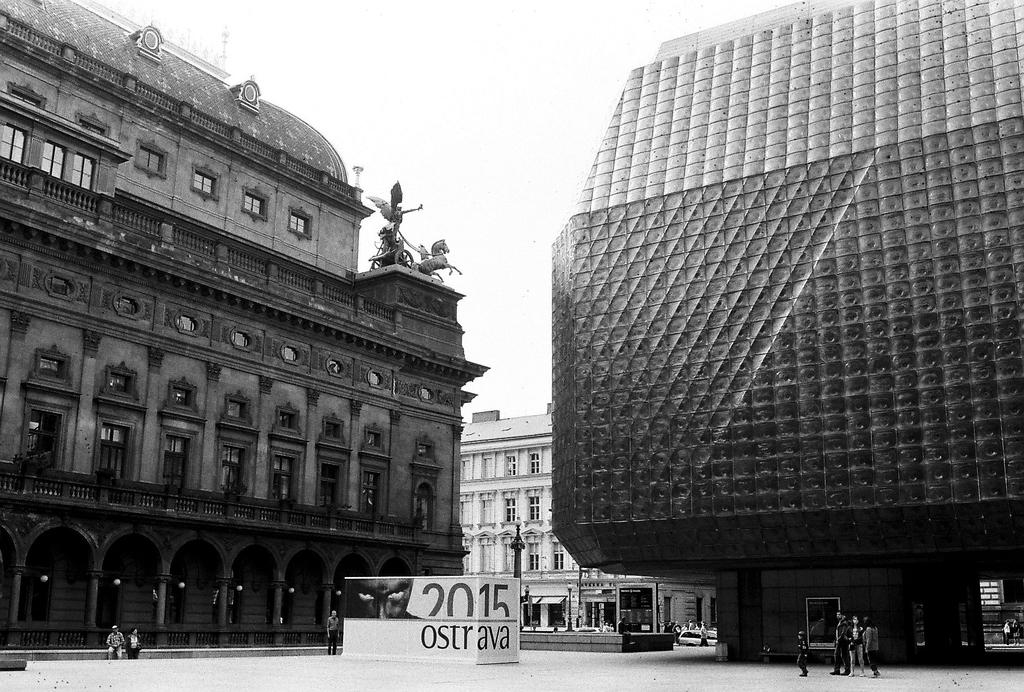What types of structures are visible in the image? There are different buildings in the image. What are the people in the image doing? People are standing on the road in the image. How are the buildings positioned in relation to the people? The buildings are in front of the people in the image. What type of things can be seen quivering in the image? There is no indication in the image of any things quivering. How does the number of buildings increase in the image? The number of buildings does not increase in the image; there are a fixed number of buildings visible. 